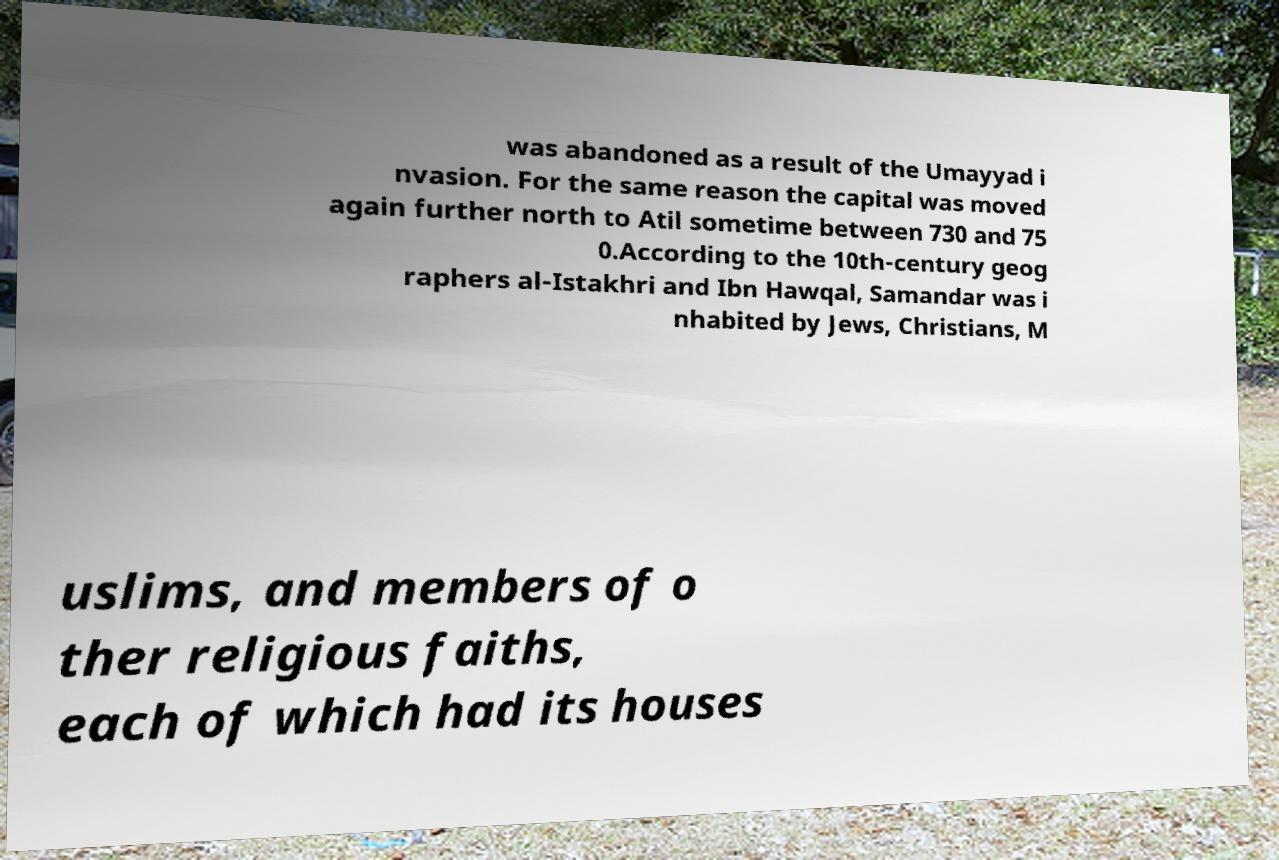There's text embedded in this image that I need extracted. Can you transcribe it verbatim? was abandoned as a result of the Umayyad i nvasion. For the same reason the capital was moved again further north to Atil sometime between 730 and 75 0.According to the 10th-century geog raphers al-Istakhri and Ibn Hawqal, Samandar was i nhabited by Jews, Christians, M uslims, and members of o ther religious faiths, each of which had its houses 